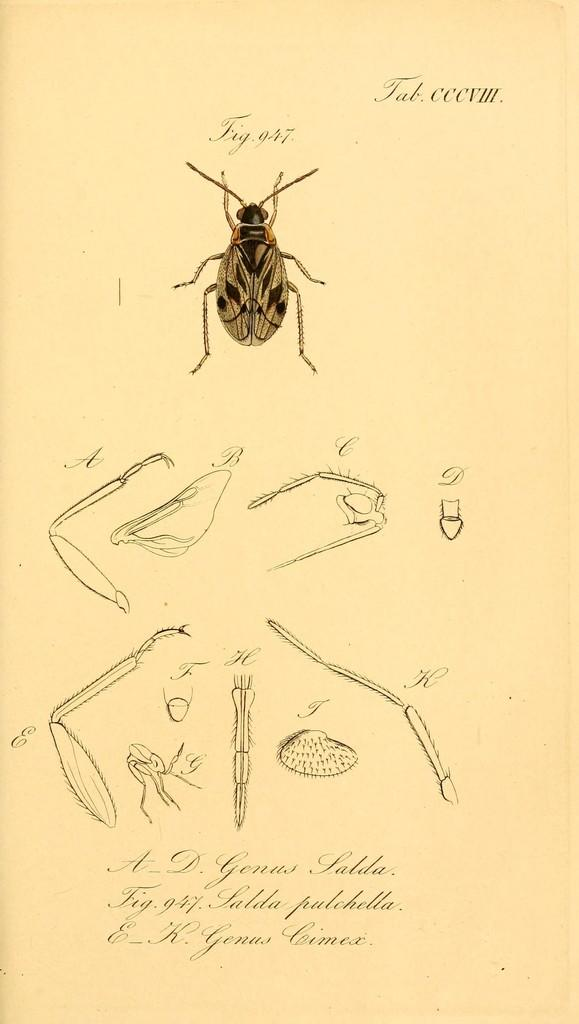What type of creature is present in the image? There is an insect in the image. Can you describe the insect in the image? The image shows the parts of the insect. What type of surprise can be seen on the door in the image? There is no door or surprise present in the image; it only features an insect and its parts. 